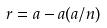Convert formula to latex. <formula><loc_0><loc_0><loc_500><loc_500>r = a - a ( a / n )</formula> 